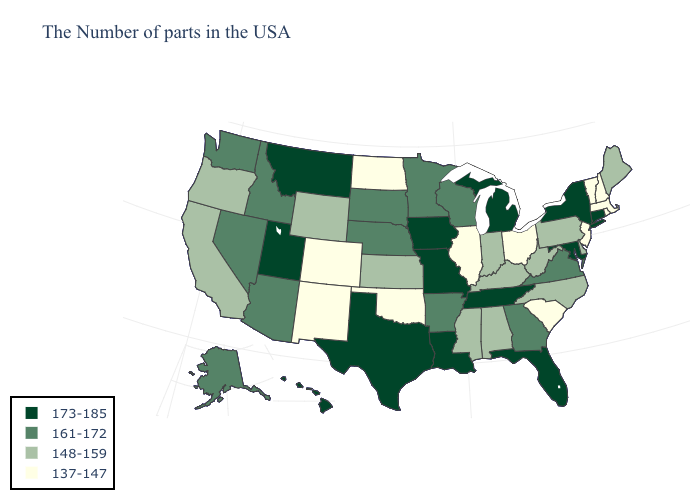What is the lowest value in the USA?
Be succinct. 137-147. Which states hav the highest value in the West?
Short answer required. Utah, Montana, Hawaii. Does Maine have the highest value in the USA?
Short answer required. No. Does the first symbol in the legend represent the smallest category?
Write a very short answer. No. What is the highest value in the USA?
Write a very short answer. 173-185. What is the value of Mississippi?
Give a very brief answer. 148-159. What is the value of California?
Answer briefly. 148-159. What is the value of Utah?
Short answer required. 173-185. Does Ohio have the highest value in the MidWest?
Quick response, please. No. Name the states that have a value in the range 137-147?
Keep it brief. Massachusetts, Rhode Island, New Hampshire, Vermont, New Jersey, South Carolina, Ohio, Illinois, Oklahoma, North Dakota, Colorado, New Mexico. Among the states that border Montana , does North Dakota have the highest value?
Short answer required. No. Is the legend a continuous bar?
Write a very short answer. No. What is the value of North Dakota?
Write a very short answer. 137-147. Does Rhode Island have the highest value in the Northeast?
Short answer required. No. Among the states that border Mississippi , does Louisiana have the lowest value?
Be succinct. No. 